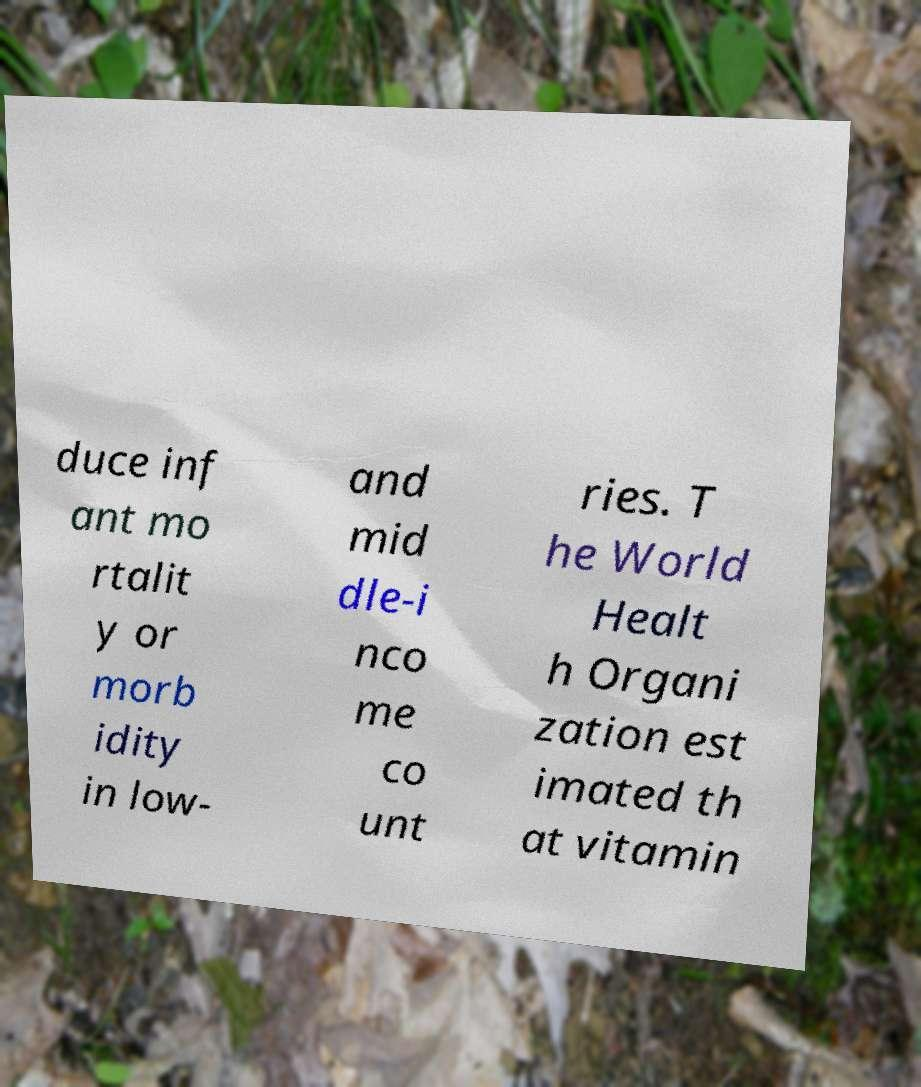Please read and relay the text visible in this image. What does it say? duce inf ant mo rtalit y or morb idity in low- and mid dle-i nco me co unt ries. T he World Healt h Organi zation est imated th at vitamin 